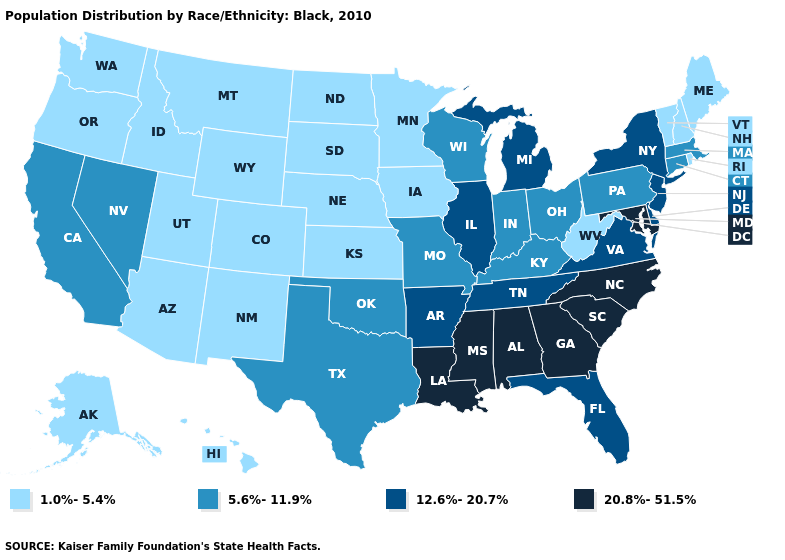Does Washington have the lowest value in the USA?
Concise answer only. Yes. Name the states that have a value in the range 20.8%-51.5%?
Short answer required. Alabama, Georgia, Louisiana, Maryland, Mississippi, North Carolina, South Carolina. Does Tennessee have the same value as Delaware?
Short answer required. Yes. Which states have the lowest value in the MidWest?
Give a very brief answer. Iowa, Kansas, Minnesota, Nebraska, North Dakota, South Dakota. Is the legend a continuous bar?
Give a very brief answer. No. What is the value of Colorado?
Quick response, please. 1.0%-5.4%. Among the states that border North Carolina , does Virginia have the lowest value?
Short answer required. Yes. Name the states that have a value in the range 5.6%-11.9%?
Short answer required. California, Connecticut, Indiana, Kentucky, Massachusetts, Missouri, Nevada, Ohio, Oklahoma, Pennsylvania, Texas, Wisconsin. What is the value of South Carolina?
Short answer required. 20.8%-51.5%. Does the first symbol in the legend represent the smallest category?
Keep it brief. Yes. What is the value of Tennessee?
Short answer required. 12.6%-20.7%. Among the states that border Delaware , does Maryland have the lowest value?
Short answer required. No. Does Iowa have the lowest value in the MidWest?
Short answer required. Yes. Does Tennessee have the lowest value in the USA?
Write a very short answer. No. Does Vermont have a higher value than Utah?
Answer briefly. No. 